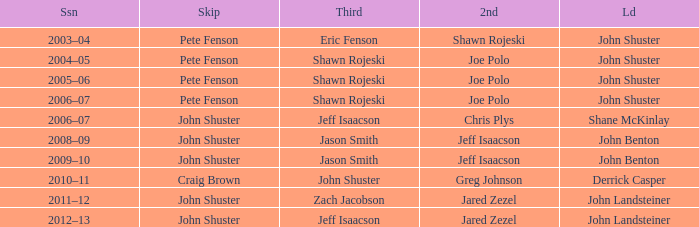Who was the lead with Pete Fenson as skip and Joe Polo as second in season 2005–06? John Shuster. 